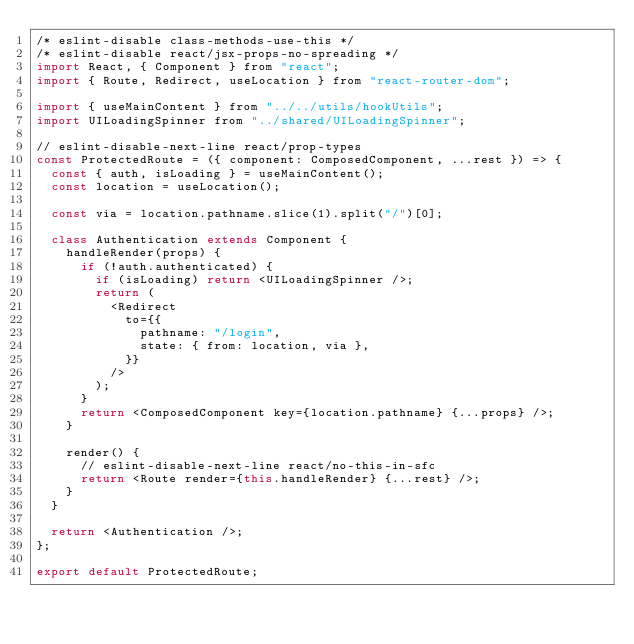<code> <loc_0><loc_0><loc_500><loc_500><_JavaScript_>/* eslint-disable class-methods-use-this */
/* eslint-disable react/jsx-props-no-spreading */
import React, { Component } from "react";
import { Route, Redirect, useLocation } from "react-router-dom";

import { useMainContent } from "../../utils/hookUtils";
import UILoadingSpinner from "../shared/UILoadingSpinner";

// eslint-disable-next-line react/prop-types
const ProtectedRoute = ({ component: ComposedComponent, ...rest }) => {
  const { auth, isLoading } = useMainContent();
  const location = useLocation();

  const via = location.pathname.slice(1).split("/")[0];

  class Authentication extends Component {
    handleRender(props) {
      if (!auth.authenticated) {
        if (isLoading) return <UILoadingSpinner />;
        return (
          <Redirect
            to={{
              pathname: "/login",
              state: { from: location, via },
            }}
          />
        );
      }
      return <ComposedComponent key={location.pathname} {...props} />;
    }

    render() {
      // eslint-disable-next-line react/no-this-in-sfc
      return <Route render={this.handleRender} {...rest} />;
    }
  }

  return <Authentication />;
};

export default ProtectedRoute;
</code> 